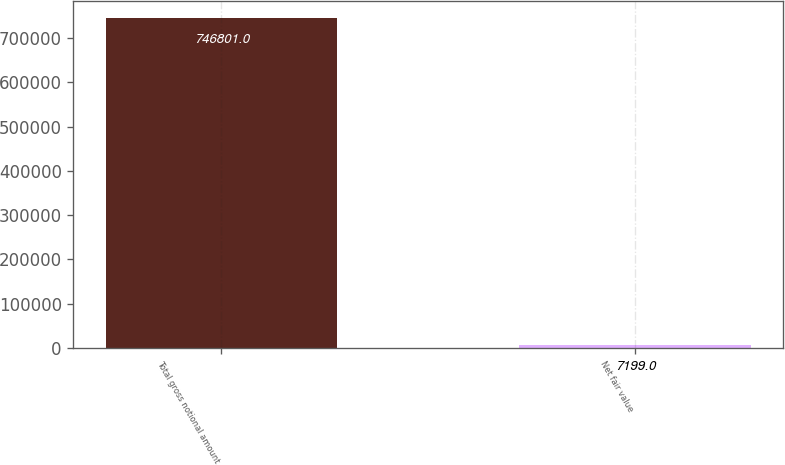<chart> <loc_0><loc_0><loc_500><loc_500><bar_chart><fcel>Total gross notional amount<fcel>Net fair value<nl><fcel>746801<fcel>7199<nl></chart> 